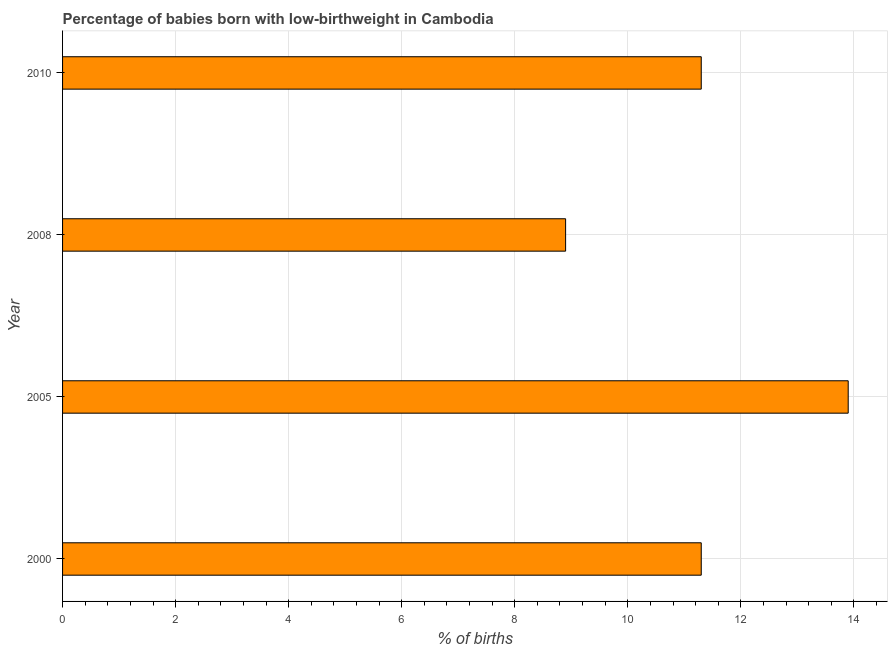Does the graph contain grids?
Your response must be concise. Yes. What is the title of the graph?
Your answer should be compact. Percentage of babies born with low-birthweight in Cambodia. What is the label or title of the X-axis?
Your response must be concise. % of births. What is the percentage of babies who were born with low-birthweight in 2000?
Ensure brevity in your answer.  11.3. What is the sum of the percentage of babies who were born with low-birthweight?
Give a very brief answer. 45.4. What is the difference between the percentage of babies who were born with low-birthweight in 2000 and 2005?
Your answer should be very brief. -2.6. What is the average percentage of babies who were born with low-birthweight per year?
Your answer should be compact. 11.35. In how many years, is the percentage of babies who were born with low-birthweight greater than 12.8 %?
Make the answer very short. 1. Do a majority of the years between 2000 and 2005 (inclusive) have percentage of babies who were born with low-birthweight greater than 10.8 %?
Make the answer very short. Yes. What is the ratio of the percentage of babies who were born with low-birthweight in 2008 to that in 2010?
Keep it short and to the point. 0.79. Is the percentage of babies who were born with low-birthweight in 2000 less than that in 2005?
Your answer should be compact. Yes. Is the difference between the percentage of babies who were born with low-birthweight in 2000 and 2010 greater than the difference between any two years?
Your answer should be compact. No. What is the difference between the highest and the second highest percentage of babies who were born with low-birthweight?
Your answer should be compact. 2.6. Is the sum of the percentage of babies who were born with low-birthweight in 2005 and 2010 greater than the maximum percentage of babies who were born with low-birthweight across all years?
Keep it short and to the point. Yes. In how many years, is the percentage of babies who were born with low-birthweight greater than the average percentage of babies who were born with low-birthweight taken over all years?
Provide a succinct answer. 1. How many bars are there?
Provide a short and direct response. 4. Are the values on the major ticks of X-axis written in scientific E-notation?
Your answer should be compact. No. What is the % of births of 2000?
Give a very brief answer. 11.3. What is the % of births of 2008?
Keep it short and to the point. 8.9. What is the difference between the % of births in 2000 and 2005?
Offer a terse response. -2.6. What is the difference between the % of births in 2000 and 2008?
Ensure brevity in your answer.  2.4. What is the difference between the % of births in 2000 and 2010?
Your answer should be very brief. 0. What is the difference between the % of births in 2005 and 2010?
Give a very brief answer. 2.6. What is the difference between the % of births in 2008 and 2010?
Give a very brief answer. -2.4. What is the ratio of the % of births in 2000 to that in 2005?
Offer a very short reply. 0.81. What is the ratio of the % of births in 2000 to that in 2008?
Your response must be concise. 1.27. What is the ratio of the % of births in 2005 to that in 2008?
Make the answer very short. 1.56. What is the ratio of the % of births in 2005 to that in 2010?
Your answer should be very brief. 1.23. What is the ratio of the % of births in 2008 to that in 2010?
Your response must be concise. 0.79. 